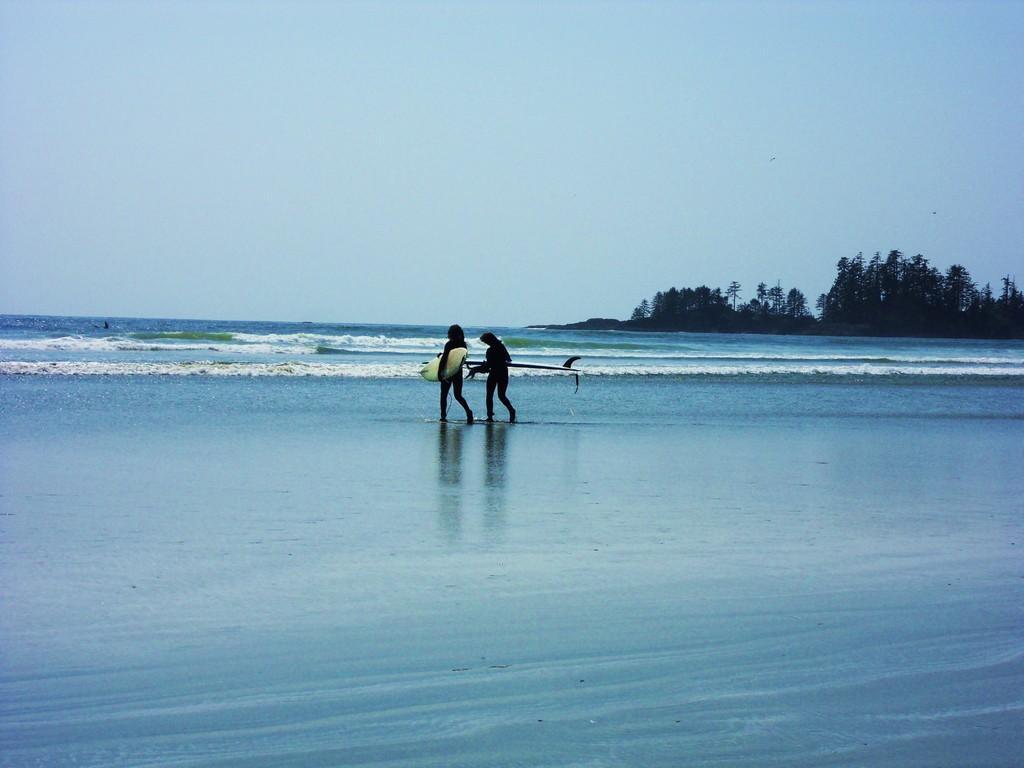Describe this image in one or two sentences. This picture might be taken on a sea shore. In this image, in the middle, we can see two persons walking on water and holding surfboard in their hands. On the right side, we can see some trees. On top there is a sky, at the bottom there is a water in a ocean. 